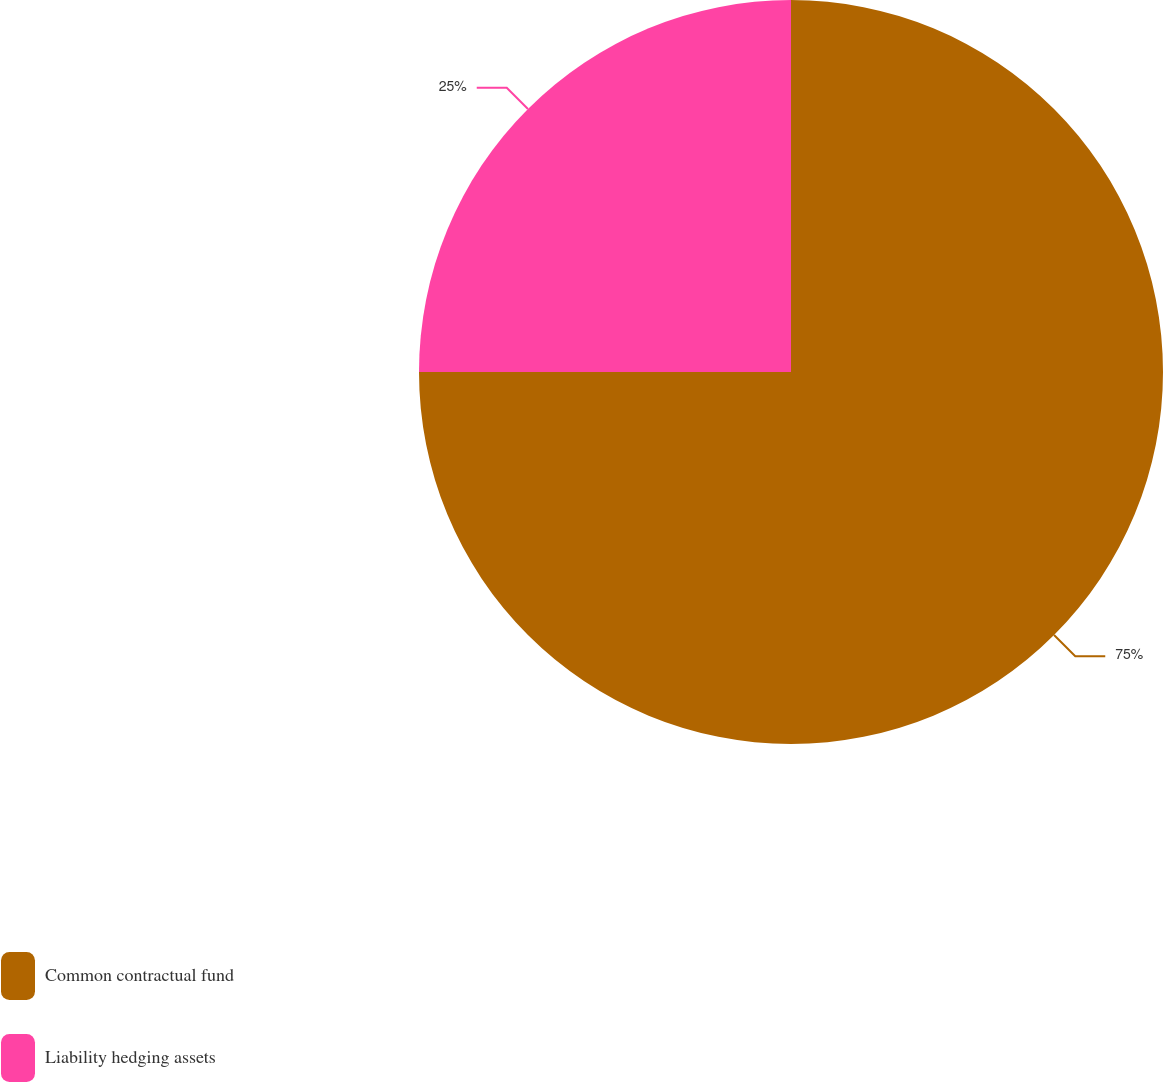Convert chart to OTSL. <chart><loc_0><loc_0><loc_500><loc_500><pie_chart><fcel>Common contractual fund<fcel>Liability hedging assets<nl><fcel>75.0%<fcel>25.0%<nl></chart> 